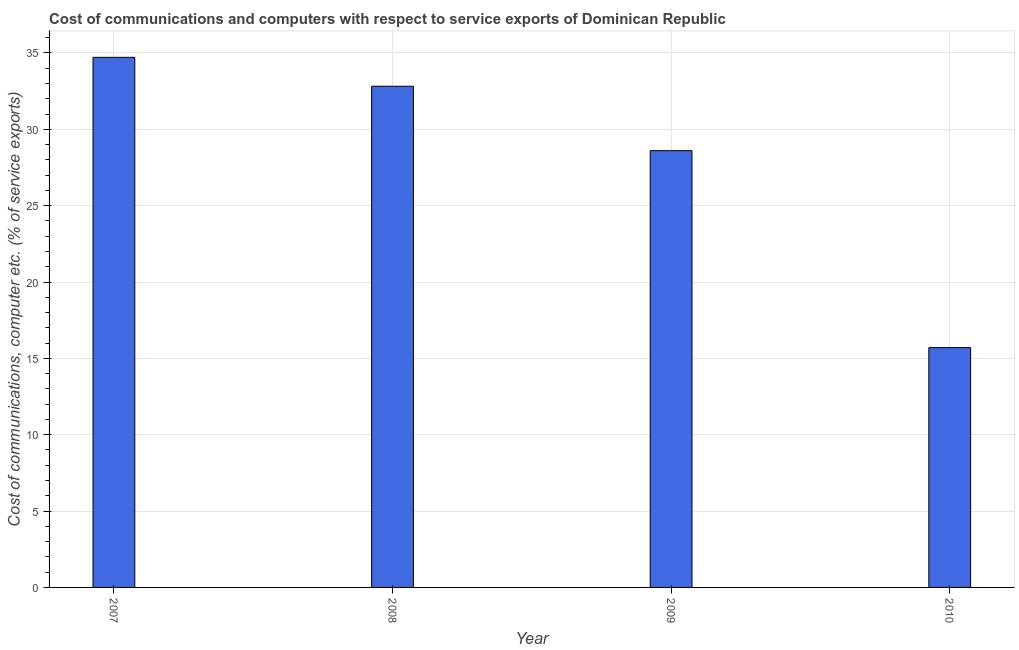Does the graph contain grids?
Keep it short and to the point. Yes. What is the title of the graph?
Your answer should be compact. Cost of communications and computers with respect to service exports of Dominican Republic. What is the label or title of the Y-axis?
Keep it short and to the point. Cost of communications, computer etc. (% of service exports). What is the cost of communications and computer in 2007?
Keep it short and to the point. 34.71. Across all years, what is the maximum cost of communications and computer?
Your answer should be very brief. 34.71. Across all years, what is the minimum cost of communications and computer?
Give a very brief answer. 15.7. In which year was the cost of communications and computer maximum?
Give a very brief answer. 2007. What is the sum of the cost of communications and computer?
Offer a very short reply. 111.84. What is the difference between the cost of communications and computer in 2008 and 2010?
Make the answer very short. 17.12. What is the average cost of communications and computer per year?
Keep it short and to the point. 27.96. What is the median cost of communications and computer?
Your response must be concise. 30.71. Do a majority of the years between 2008 and 2007 (inclusive) have cost of communications and computer greater than 26 %?
Offer a very short reply. No. What is the ratio of the cost of communications and computer in 2008 to that in 2009?
Provide a succinct answer. 1.15. Is the cost of communications and computer in 2008 less than that in 2009?
Ensure brevity in your answer.  No. Is the difference between the cost of communications and computer in 2008 and 2009 greater than the difference between any two years?
Provide a succinct answer. No. What is the difference between the highest and the second highest cost of communications and computer?
Your answer should be compact. 1.89. Is the sum of the cost of communications and computer in 2007 and 2009 greater than the maximum cost of communications and computer across all years?
Provide a succinct answer. Yes. What is the difference between the highest and the lowest cost of communications and computer?
Your answer should be very brief. 19.01. What is the difference between two consecutive major ticks on the Y-axis?
Provide a short and direct response. 5. Are the values on the major ticks of Y-axis written in scientific E-notation?
Provide a succinct answer. No. What is the Cost of communications, computer etc. (% of service exports) in 2007?
Provide a succinct answer. 34.71. What is the Cost of communications, computer etc. (% of service exports) of 2008?
Offer a terse response. 32.82. What is the Cost of communications, computer etc. (% of service exports) of 2009?
Your answer should be compact. 28.6. What is the Cost of communications, computer etc. (% of service exports) of 2010?
Make the answer very short. 15.7. What is the difference between the Cost of communications, computer etc. (% of service exports) in 2007 and 2008?
Your answer should be very brief. 1.89. What is the difference between the Cost of communications, computer etc. (% of service exports) in 2007 and 2009?
Ensure brevity in your answer.  6.11. What is the difference between the Cost of communications, computer etc. (% of service exports) in 2007 and 2010?
Ensure brevity in your answer.  19.01. What is the difference between the Cost of communications, computer etc. (% of service exports) in 2008 and 2009?
Make the answer very short. 4.22. What is the difference between the Cost of communications, computer etc. (% of service exports) in 2008 and 2010?
Keep it short and to the point. 17.12. What is the difference between the Cost of communications, computer etc. (% of service exports) in 2009 and 2010?
Keep it short and to the point. 12.9. What is the ratio of the Cost of communications, computer etc. (% of service exports) in 2007 to that in 2008?
Give a very brief answer. 1.06. What is the ratio of the Cost of communications, computer etc. (% of service exports) in 2007 to that in 2009?
Give a very brief answer. 1.21. What is the ratio of the Cost of communications, computer etc. (% of service exports) in 2007 to that in 2010?
Your response must be concise. 2.21. What is the ratio of the Cost of communications, computer etc. (% of service exports) in 2008 to that in 2009?
Provide a short and direct response. 1.15. What is the ratio of the Cost of communications, computer etc. (% of service exports) in 2008 to that in 2010?
Ensure brevity in your answer.  2.09. What is the ratio of the Cost of communications, computer etc. (% of service exports) in 2009 to that in 2010?
Ensure brevity in your answer.  1.82. 